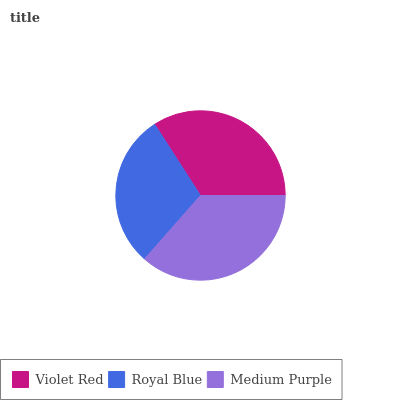Is Royal Blue the minimum?
Answer yes or no. Yes. Is Medium Purple the maximum?
Answer yes or no. Yes. Is Medium Purple the minimum?
Answer yes or no. No. Is Royal Blue the maximum?
Answer yes or no. No. Is Medium Purple greater than Royal Blue?
Answer yes or no. Yes. Is Royal Blue less than Medium Purple?
Answer yes or no. Yes. Is Royal Blue greater than Medium Purple?
Answer yes or no. No. Is Medium Purple less than Royal Blue?
Answer yes or no. No. Is Violet Red the high median?
Answer yes or no. Yes. Is Violet Red the low median?
Answer yes or no. Yes. Is Medium Purple the high median?
Answer yes or no. No. Is Royal Blue the low median?
Answer yes or no. No. 